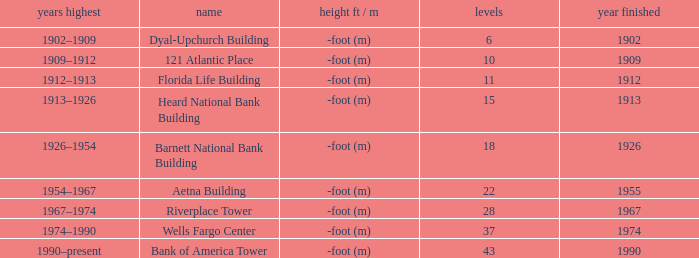How tall is the florida life building, completed before 1990? -foot (m). Parse the table in full. {'header': ['years highest', 'name', 'height ft / m', 'levels', 'year finished'], 'rows': [['1902–1909', 'Dyal-Upchurch Building', '-foot (m)', '6', '1902'], ['1909–1912', '121 Atlantic Place', '-foot (m)', '10', '1909'], ['1912–1913', 'Florida Life Building', '-foot (m)', '11', '1912'], ['1913–1926', 'Heard National Bank Building', '-foot (m)', '15', '1913'], ['1926–1954', 'Barnett National Bank Building', '-foot (m)', '18', '1926'], ['1954–1967', 'Aetna Building', '-foot (m)', '22', '1955'], ['1967–1974', 'Riverplace Tower', '-foot (m)', '28', '1967'], ['1974–1990', 'Wells Fargo Center', '-foot (m)', '37', '1974'], ['1990–present', 'Bank of America Tower', '-foot (m)', '43', '1990']]} 